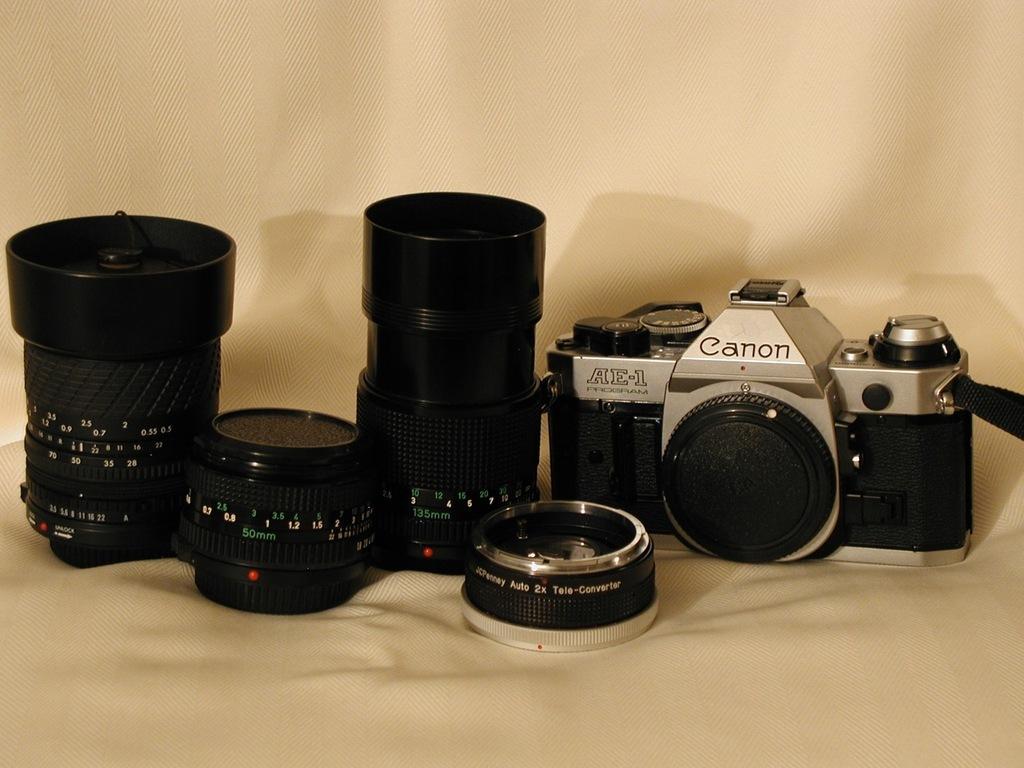Could you give a brief overview of what you see in this image? On the left side, there are lenses arranged on a cloth. On the right side, there is a camera arranged on the cloth. And the background is white in color. 